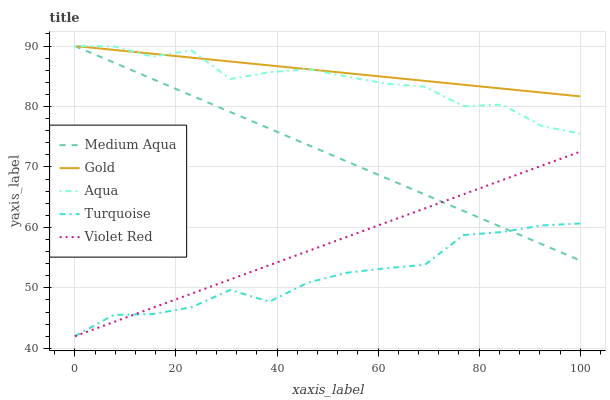Does Turquoise have the minimum area under the curve?
Answer yes or no. Yes. Does Gold have the maximum area under the curve?
Answer yes or no. Yes. Does Medium Aqua have the minimum area under the curve?
Answer yes or no. No. Does Medium Aqua have the maximum area under the curve?
Answer yes or no. No. Is Violet Red the smoothest?
Answer yes or no. Yes. Is Aqua the roughest?
Answer yes or no. Yes. Is Turquoise the smoothest?
Answer yes or no. No. Is Turquoise the roughest?
Answer yes or no. No. Does Turquoise have the lowest value?
Answer yes or no. Yes. Does Medium Aqua have the lowest value?
Answer yes or no. No. Does Gold have the highest value?
Answer yes or no. Yes. Does Turquoise have the highest value?
Answer yes or no. No. Is Violet Red less than Gold?
Answer yes or no. Yes. Is Aqua greater than Turquoise?
Answer yes or no. Yes. Does Turquoise intersect Violet Red?
Answer yes or no. Yes. Is Turquoise less than Violet Red?
Answer yes or no. No. Is Turquoise greater than Violet Red?
Answer yes or no. No. Does Violet Red intersect Gold?
Answer yes or no. No. 